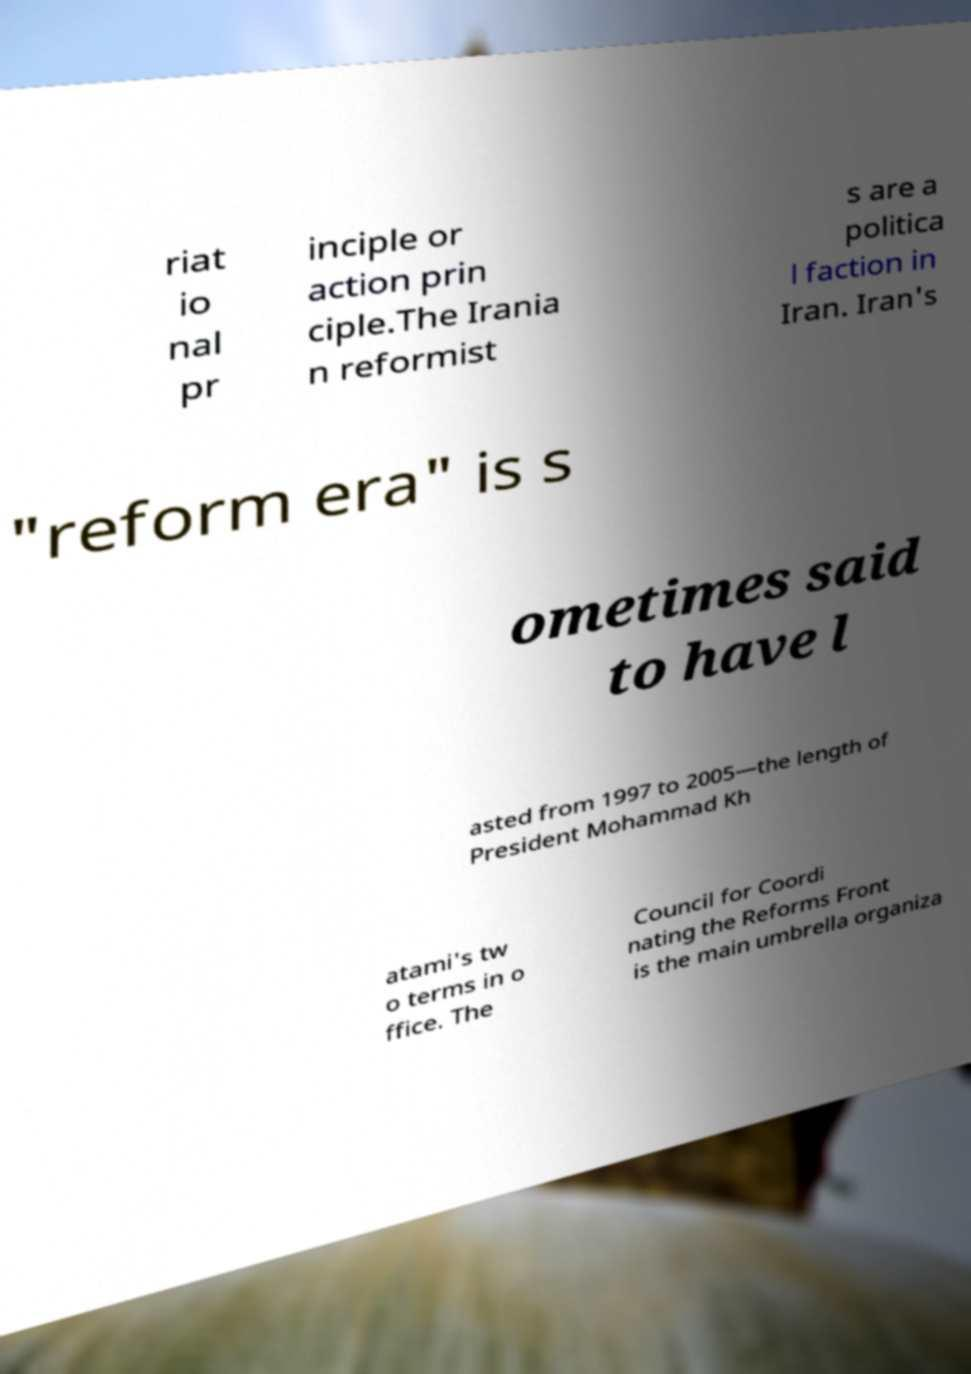For documentation purposes, I need the text within this image transcribed. Could you provide that? riat io nal pr inciple or action prin ciple.The Irania n reformist s are a politica l faction in Iran. Iran's "reform era" is s ometimes said to have l asted from 1997 to 2005—the length of President Mohammad Kh atami's tw o terms in o ffice. The Council for Coordi nating the Reforms Front is the main umbrella organiza 